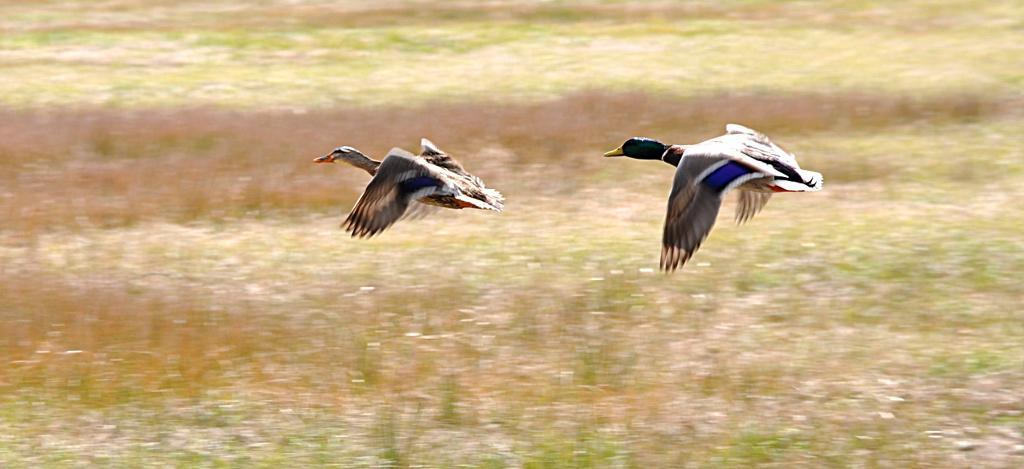What animals can be seen in the image? There are two birds flying in the air. What type of vegetation is visible at the bottom of the image? There is grass visible at the bottom of the image. What type of disease is affecting the birds in the image? There is no indication of any disease affecting the birds in the image; they appear to be flying normally. 